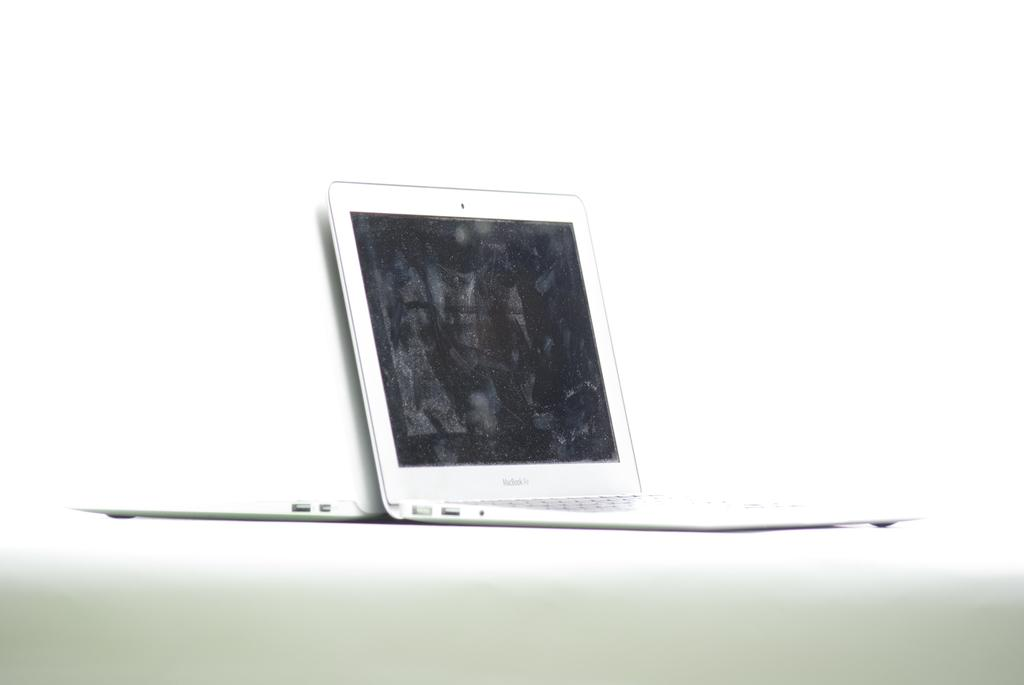What electronic device is visible in the image? There is a laptop in the image. On what surface is the laptop placed? The laptop is placed on a white surface. What type of note is being passed between the two people in the image? There are no people or notes present in the image; it only features a laptop placed on a white surface. 